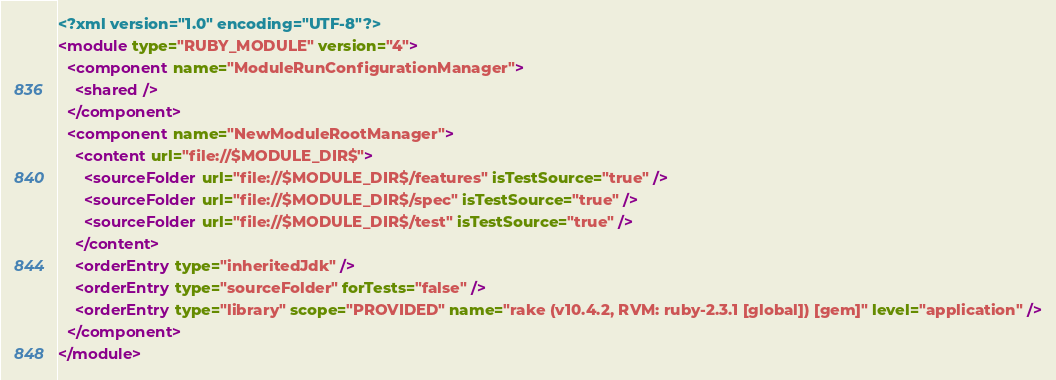<code> <loc_0><loc_0><loc_500><loc_500><_XML_><?xml version="1.0" encoding="UTF-8"?>
<module type="RUBY_MODULE" version="4">
  <component name="ModuleRunConfigurationManager">
    <shared />
  </component>
  <component name="NewModuleRootManager">
    <content url="file://$MODULE_DIR$">
      <sourceFolder url="file://$MODULE_DIR$/features" isTestSource="true" />
      <sourceFolder url="file://$MODULE_DIR$/spec" isTestSource="true" />
      <sourceFolder url="file://$MODULE_DIR$/test" isTestSource="true" />
    </content>
    <orderEntry type="inheritedJdk" />
    <orderEntry type="sourceFolder" forTests="false" />
    <orderEntry type="library" scope="PROVIDED" name="rake (v10.4.2, RVM: ruby-2.3.1 [global]) [gem]" level="application" />
  </component>
</module></code> 